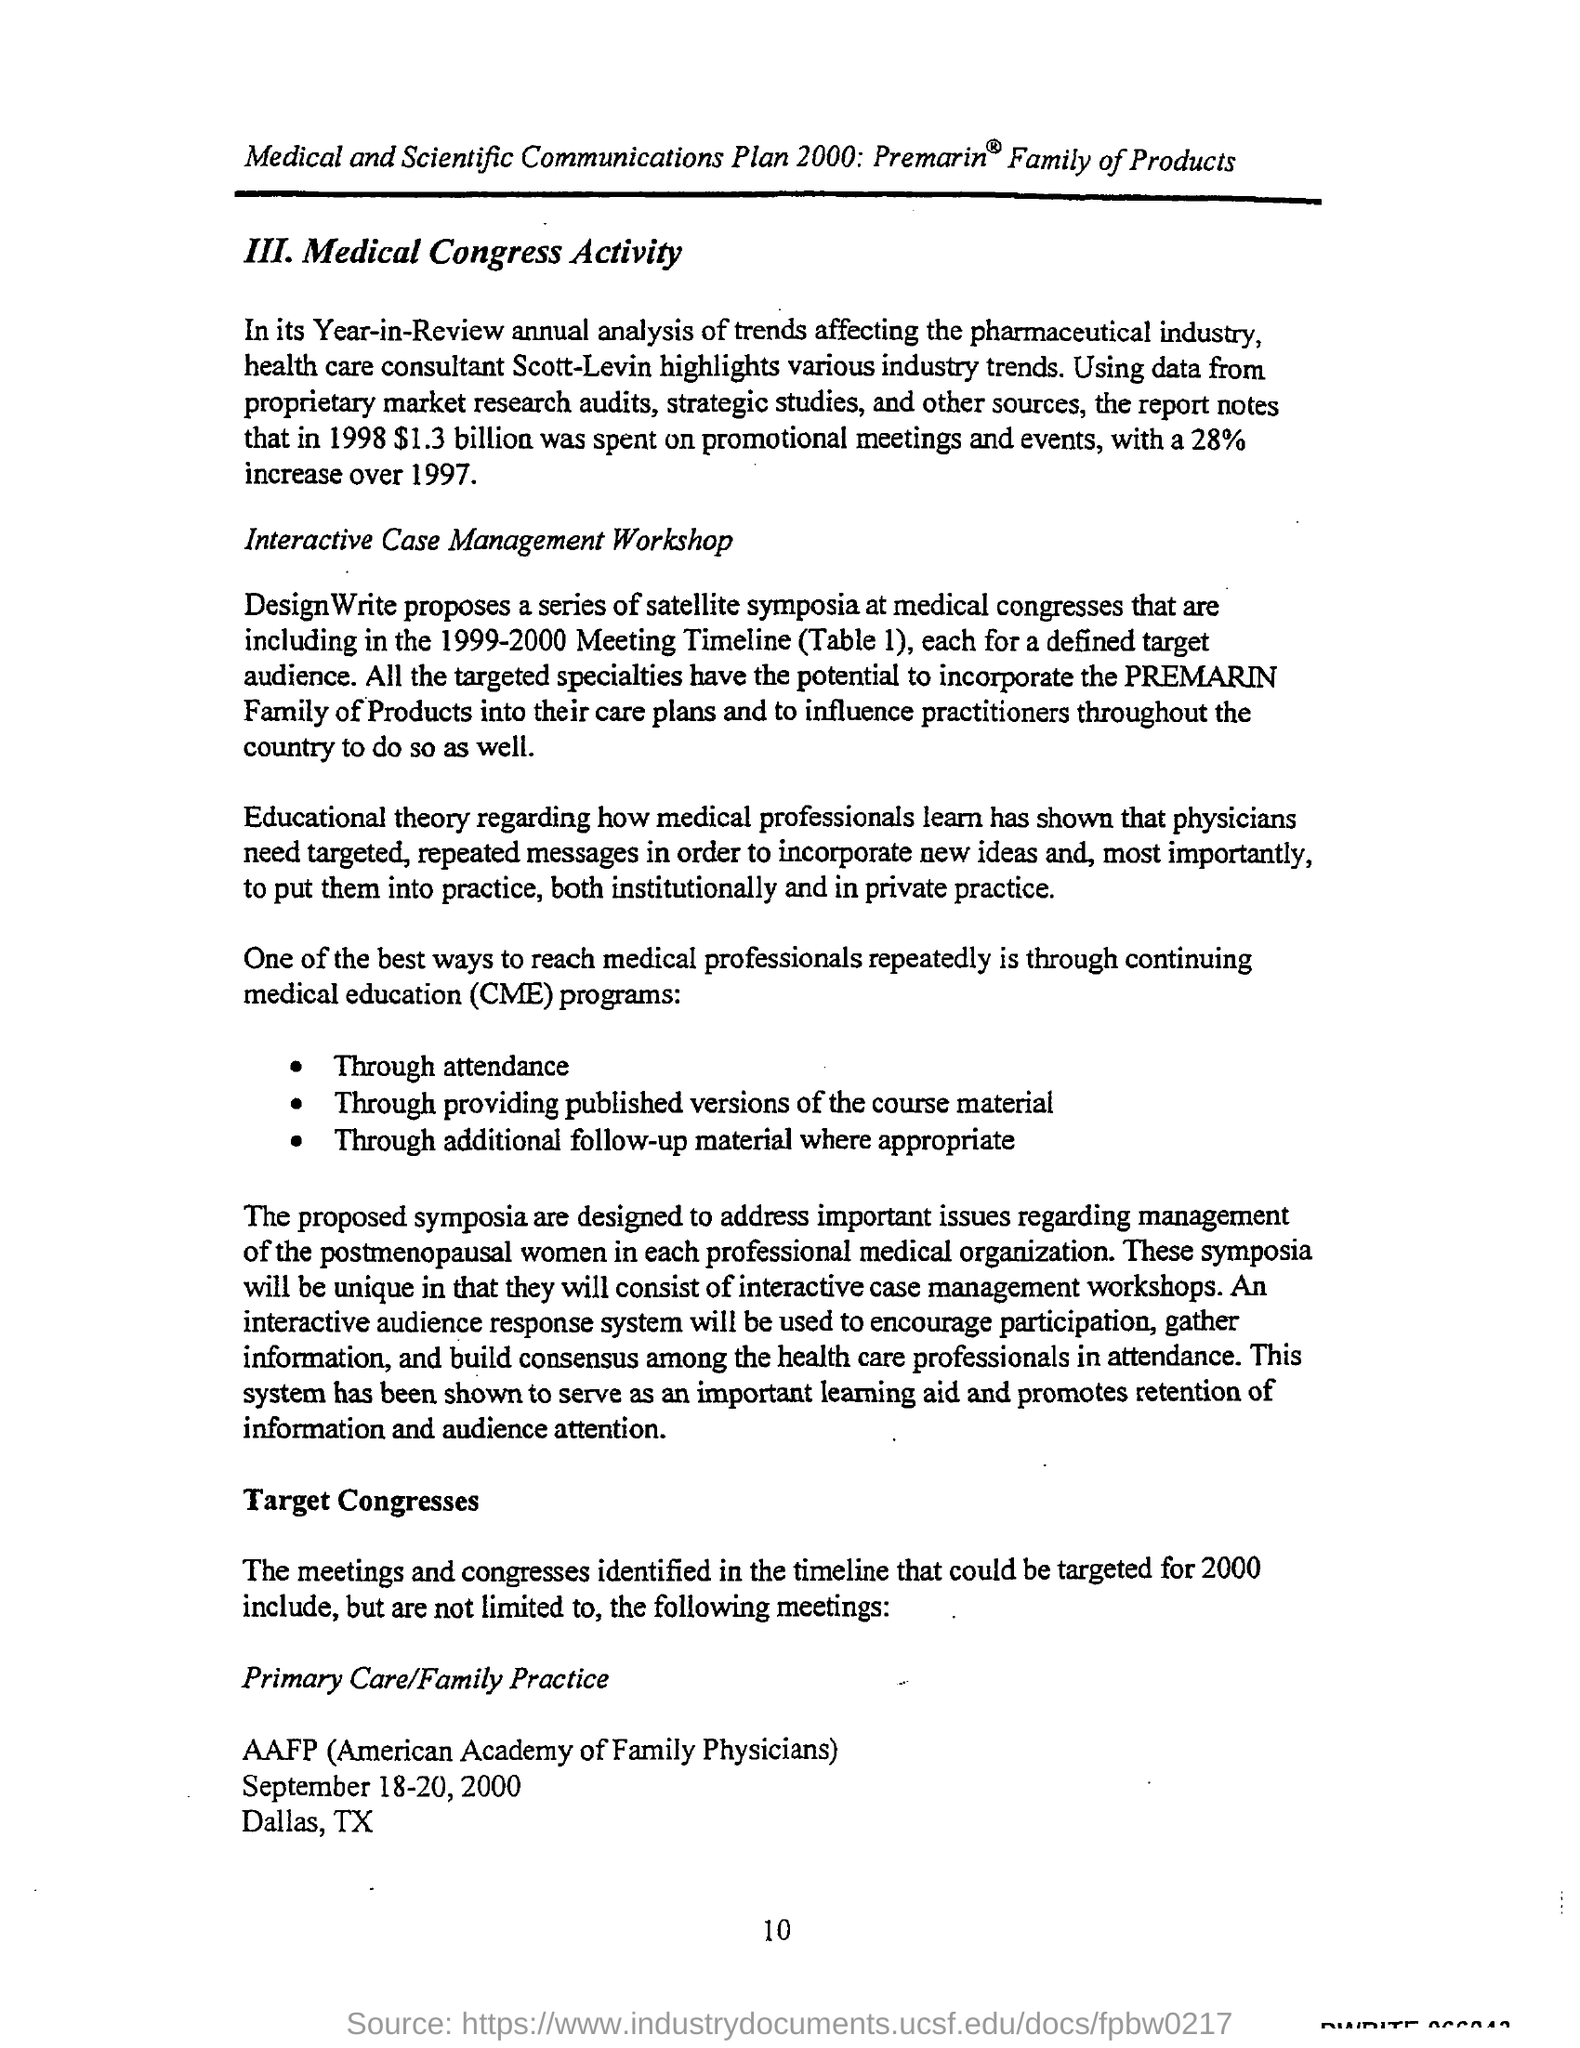What is the Page Number?
Your answer should be very brief. 10. 